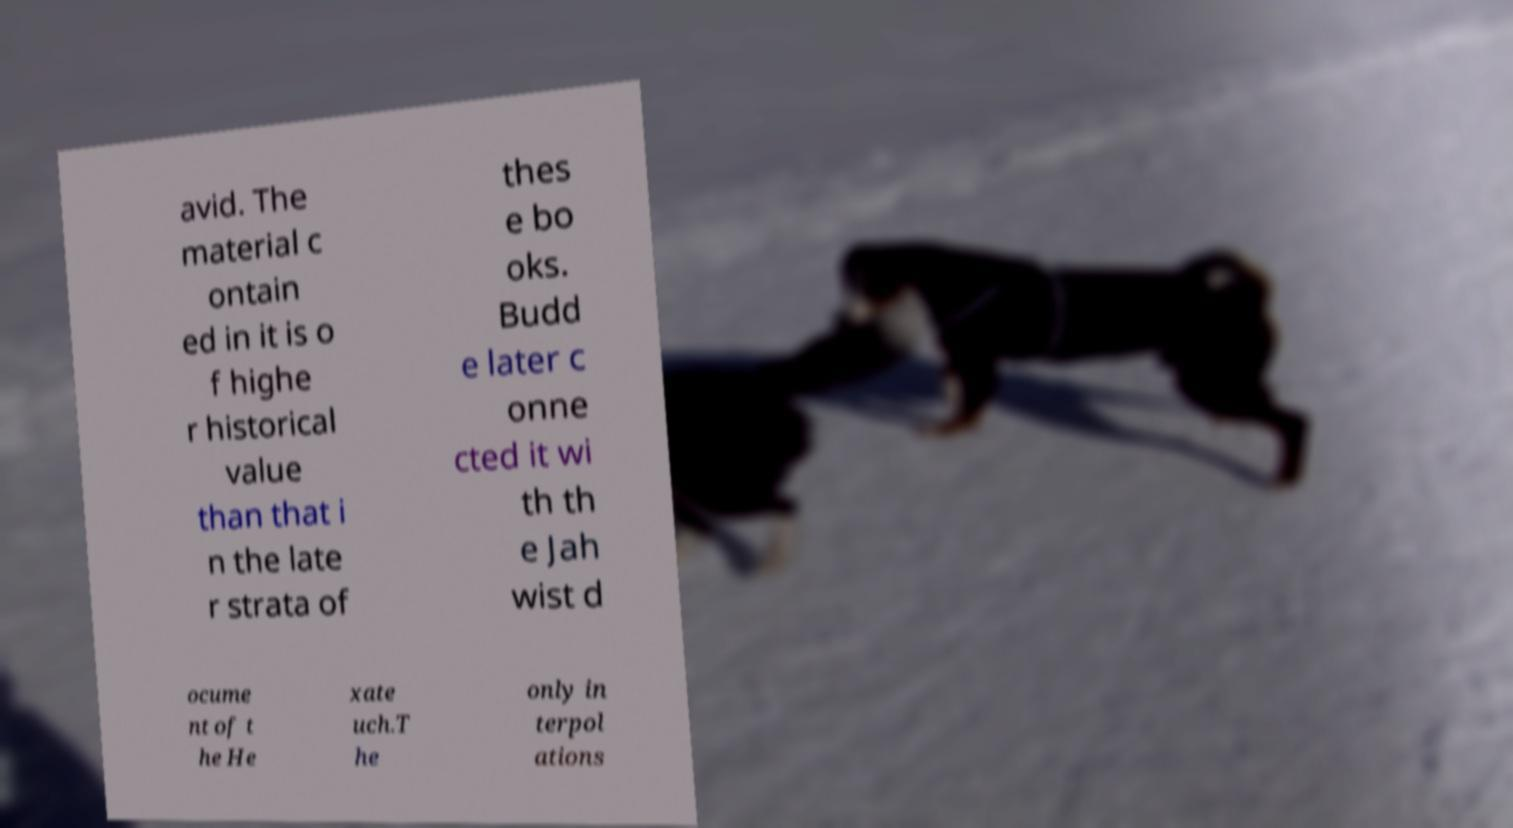Can you accurately transcribe the text from the provided image for me? avid. The material c ontain ed in it is o f highe r historical value than that i n the late r strata of thes e bo oks. Budd e later c onne cted it wi th th e Jah wist d ocume nt of t he He xate uch.T he only in terpol ations 